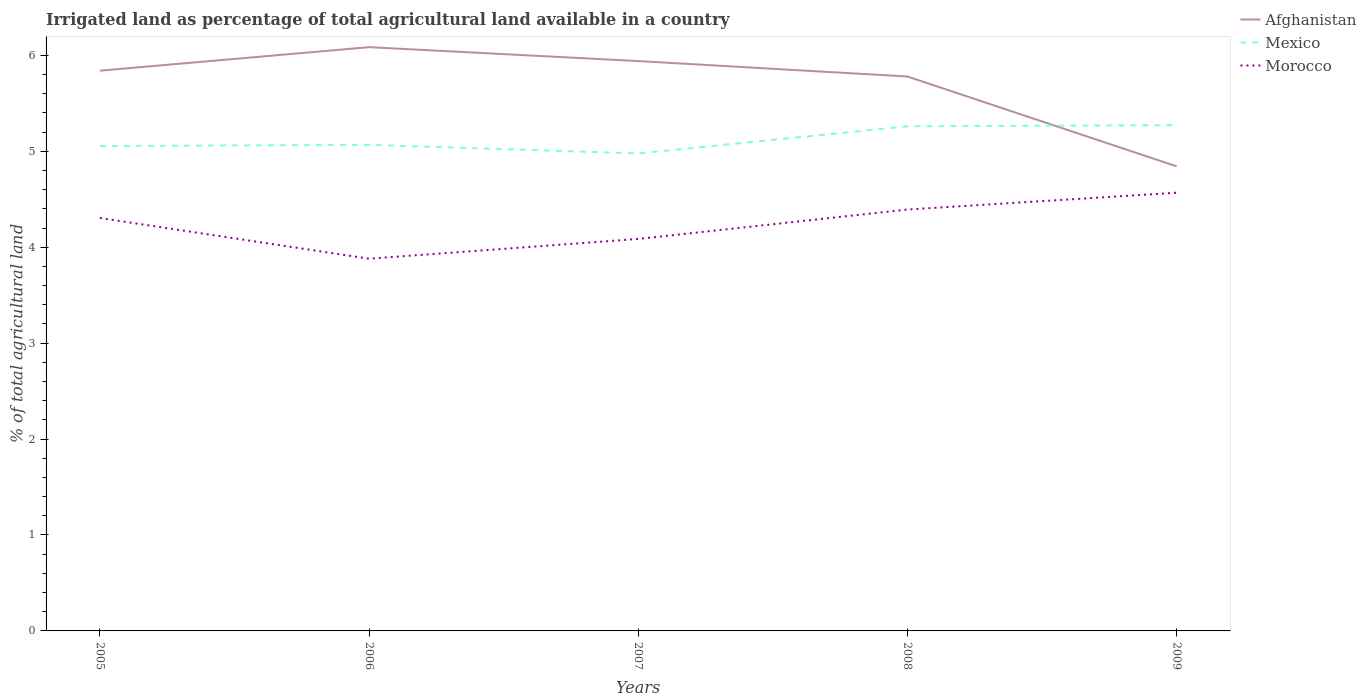Does the line corresponding to Morocco intersect with the line corresponding to Mexico?
Offer a very short reply. No. Across all years, what is the maximum percentage of irrigated land in Afghanistan?
Your answer should be compact. 4.84. In which year was the percentage of irrigated land in Afghanistan maximum?
Provide a short and direct response. 2009. What is the total percentage of irrigated land in Morocco in the graph?
Your answer should be very brief. -0.31. What is the difference between the highest and the second highest percentage of irrigated land in Afghanistan?
Provide a short and direct response. 1.24. Is the percentage of irrigated land in Mexico strictly greater than the percentage of irrigated land in Afghanistan over the years?
Ensure brevity in your answer.  No. How many lines are there?
Ensure brevity in your answer.  3. What is the difference between two consecutive major ticks on the Y-axis?
Your answer should be compact. 1. Are the values on the major ticks of Y-axis written in scientific E-notation?
Provide a short and direct response. No. Does the graph contain any zero values?
Your answer should be very brief. No. Where does the legend appear in the graph?
Make the answer very short. Top right. How many legend labels are there?
Keep it short and to the point. 3. What is the title of the graph?
Keep it short and to the point. Irrigated land as percentage of total agricultural land available in a country. Does "Chile" appear as one of the legend labels in the graph?
Your answer should be compact. No. What is the label or title of the X-axis?
Keep it short and to the point. Years. What is the label or title of the Y-axis?
Offer a very short reply. % of total agricultural land. What is the % of total agricultural land in Afghanistan in 2005?
Provide a succinct answer. 5.84. What is the % of total agricultural land in Mexico in 2005?
Offer a terse response. 5.05. What is the % of total agricultural land in Morocco in 2005?
Ensure brevity in your answer.  4.3. What is the % of total agricultural land of Afghanistan in 2006?
Make the answer very short. 6.09. What is the % of total agricultural land of Mexico in 2006?
Ensure brevity in your answer.  5.07. What is the % of total agricultural land of Morocco in 2006?
Make the answer very short. 3.88. What is the % of total agricultural land of Afghanistan in 2007?
Keep it short and to the point. 5.94. What is the % of total agricultural land of Mexico in 2007?
Ensure brevity in your answer.  4.98. What is the % of total agricultural land in Morocco in 2007?
Your response must be concise. 4.09. What is the % of total agricultural land of Afghanistan in 2008?
Provide a short and direct response. 5.78. What is the % of total agricultural land in Mexico in 2008?
Offer a very short reply. 5.26. What is the % of total agricultural land of Morocco in 2008?
Keep it short and to the point. 4.39. What is the % of total agricultural land in Afghanistan in 2009?
Ensure brevity in your answer.  4.84. What is the % of total agricultural land of Mexico in 2009?
Keep it short and to the point. 5.27. What is the % of total agricultural land of Morocco in 2009?
Offer a very short reply. 4.57. Across all years, what is the maximum % of total agricultural land in Afghanistan?
Provide a short and direct response. 6.09. Across all years, what is the maximum % of total agricultural land of Mexico?
Your answer should be very brief. 5.27. Across all years, what is the maximum % of total agricultural land in Morocco?
Provide a succinct answer. 4.57. Across all years, what is the minimum % of total agricultural land in Afghanistan?
Ensure brevity in your answer.  4.84. Across all years, what is the minimum % of total agricultural land in Mexico?
Your answer should be very brief. 4.98. Across all years, what is the minimum % of total agricultural land in Morocco?
Your answer should be compact. 3.88. What is the total % of total agricultural land of Afghanistan in the graph?
Provide a short and direct response. 28.49. What is the total % of total agricultural land in Mexico in the graph?
Make the answer very short. 25.63. What is the total % of total agricultural land in Morocco in the graph?
Keep it short and to the point. 21.23. What is the difference between the % of total agricultural land in Afghanistan in 2005 and that in 2006?
Provide a short and direct response. -0.25. What is the difference between the % of total agricultural land in Mexico in 2005 and that in 2006?
Your response must be concise. -0.01. What is the difference between the % of total agricultural land of Morocco in 2005 and that in 2006?
Provide a short and direct response. 0.42. What is the difference between the % of total agricultural land of Afghanistan in 2005 and that in 2007?
Give a very brief answer. -0.1. What is the difference between the % of total agricultural land of Mexico in 2005 and that in 2007?
Keep it short and to the point. 0.08. What is the difference between the % of total agricultural land of Morocco in 2005 and that in 2007?
Provide a succinct answer. 0.22. What is the difference between the % of total agricultural land in Afghanistan in 2005 and that in 2008?
Give a very brief answer. 0.06. What is the difference between the % of total agricultural land in Mexico in 2005 and that in 2008?
Your answer should be compact. -0.21. What is the difference between the % of total agricultural land in Morocco in 2005 and that in 2008?
Your answer should be compact. -0.09. What is the difference between the % of total agricultural land of Mexico in 2005 and that in 2009?
Offer a very short reply. -0.22. What is the difference between the % of total agricultural land in Morocco in 2005 and that in 2009?
Offer a very short reply. -0.26. What is the difference between the % of total agricultural land in Afghanistan in 2006 and that in 2007?
Ensure brevity in your answer.  0.15. What is the difference between the % of total agricultural land in Mexico in 2006 and that in 2007?
Your answer should be compact. 0.09. What is the difference between the % of total agricultural land in Morocco in 2006 and that in 2007?
Your answer should be compact. -0.21. What is the difference between the % of total agricultural land of Afghanistan in 2006 and that in 2008?
Your response must be concise. 0.31. What is the difference between the % of total agricultural land of Mexico in 2006 and that in 2008?
Offer a terse response. -0.19. What is the difference between the % of total agricultural land of Morocco in 2006 and that in 2008?
Your response must be concise. -0.51. What is the difference between the % of total agricultural land of Afghanistan in 2006 and that in 2009?
Provide a succinct answer. 1.24. What is the difference between the % of total agricultural land of Mexico in 2006 and that in 2009?
Keep it short and to the point. -0.21. What is the difference between the % of total agricultural land of Morocco in 2006 and that in 2009?
Provide a succinct answer. -0.69. What is the difference between the % of total agricultural land in Afghanistan in 2007 and that in 2008?
Ensure brevity in your answer.  0.16. What is the difference between the % of total agricultural land in Mexico in 2007 and that in 2008?
Make the answer very short. -0.28. What is the difference between the % of total agricultural land of Morocco in 2007 and that in 2008?
Your answer should be compact. -0.31. What is the difference between the % of total agricultural land of Afghanistan in 2007 and that in 2009?
Your answer should be very brief. 1.1. What is the difference between the % of total agricultural land in Mexico in 2007 and that in 2009?
Your answer should be compact. -0.29. What is the difference between the % of total agricultural land of Morocco in 2007 and that in 2009?
Give a very brief answer. -0.48. What is the difference between the % of total agricultural land of Afghanistan in 2008 and that in 2009?
Your answer should be very brief. 0.94. What is the difference between the % of total agricultural land in Mexico in 2008 and that in 2009?
Provide a short and direct response. -0.01. What is the difference between the % of total agricultural land of Morocco in 2008 and that in 2009?
Keep it short and to the point. -0.18. What is the difference between the % of total agricultural land of Afghanistan in 2005 and the % of total agricultural land of Mexico in 2006?
Provide a succinct answer. 0.77. What is the difference between the % of total agricultural land in Afghanistan in 2005 and the % of total agricultural land in Morocco in 2006?
Give a very brief answer. 1.96. What is the difference between the % of total agricultural land of Mexico in 2005 and the % of total agricultural land of Morocco in 2006?
Offer a very short reply. 1.17. What is the difference between the % of total agricultural land in Afghanistan in 2005 and the % of total agricultural land in Mexico in 2007?
Offer a terse response. 0.86. What is the difference between the % of total agricultural land in Afghanistan in 2005 and the % of total agricultural land in Morocco in 2007?
Provide a succinct answer. 1.75. What is the difference between the % of total agricultural land of Mexico in 2005 and the % of total agricultural land of Morocco in 2007?
Offer a very short reply. 0.97. What is the difference between the % of total agricultural land of Afghanistan in 2005 and the % of total agricultural land of Mexico in 2008?
Ensure brevity in your answer.  0.58. What is the difference between the % of total agricultural land of Afghanistan in 2005 and the % of total agricultural land of Morocco in 2008?
Offer a very short reply. 1.45. What is the difference between the % of total agricultural land of Mexico in 2005 and the % of total agricultural land of Morocco in 2008?
Offer a very short reply. 0.66. What is the difference between the % of total agricultural land of Afghanistan in 2005 and the % of total agricultural land of Mexico in 2009?
Your response must be concise. 0.57. What is the difference between the % of total agricultural land of Afghanistan in 2005 and the % of total agricultural land of Morocco in 2009?
Provide a succinct answer. 1.27. What is the difference between the % of total agricultural land in Mexico in 2005 and the % of total agricultural land in Morocco in 2009?
Your answer should be compact. 0.49. What is the difference between the % of total agricultural land of Afghanistan in 2006 and the % of total agricultural land of Mexico in 2007?
Make the answer very short. 1.11. What is the difference between the % of total agricultural land of Afghanistan in 2006 and the % of total agricultural land of Morocco in 2007?
Your answer should be compact. 2. What is the difference between the % of total agricultural land in Mexico in 2006 and the % of total agricultural land in Morocco in 2007?
Make the answer very short. 0.98. What is the difference between the % of total agricultural land in Afghanistan in 2006 and the % of total agricultural land in Mexico in 2008?
Offer a terse response. 0.83. What is the difference between the % of total agricultural land of Afghanistan in 2006 and the % of total agricultural land of Morocco in 2008?
Make the answer very short. 1.69. What is the difference between the % of total agricultural land in Mexico in 2006 and the % of total agricultural land in Morocco in 2008?
Keep it short and to the point. 0.67. What is the difference between the % of total agricultural land in Afghanistan in 2006 and the % of total agricultural land in Mexico in 2009?
Offer a terse response. 0.81. What is the difference between the % of total agricultural land in Afghanistan in 2006 and the % of total agricultural land in Morocco in 2009?
Your response must be concise. 1.52. What is the difference between the % of total agricultural land of Mexico in 2006 and the % of total agricultural land of Morocco in 2009?
Your response must be concise. 0.5. What is the difference between the % of total agricultural land of Afghanistan in 2007 and the % of total agricultural land of Mexico in 2008?
Provide a short and direct response. 0.68. What is the difference between the % of total agricultural land in Afghanistan in 2007 and the % of total agricultural land in Morocco in 2008?
Provide a short and direct response. 1.55. What is the difference between the % of total agricultural land of Mexico in 2007 and the % of total agricultural land of Morocco in 2008?
Keep it short and to the point. 0.58. What is the difference between the % of total agricultural land of Afghanistan in 2007 and the % of total agricultural land of Mexico in 2009?
Provide a short and direct response. 0.67. What is the difference between the % of total agricultural land in Afghanistan in 2007 and the % of total agricultural land in Morocco in 2009?
Offer a terse response. 1.37. What is the difference between the % of total agricultural land in Mexico in 2007 and the % of total agricultural land in Morocco in 2009?
Provide a short and direct response. 0.41. What is the difference between the % of total agricultural land of Afghanistan in 2008 and the % of total agricultural land of Mexico in 2009?
Offer a terse response. 0.51. What is the difference between the % of total agricultural land of Afghanistan in 2008 and the % of total agricultural land of Morocco in 2009?
Your answer should be compact. 1.21. What is the difference between the % of total agricultural land of Mexico in 2008 and the % of total agricultural land of Morocco in 2009?
Offer a very short reply. 0.69. What is the average % of total agricultural land in Afghanistan per year?
Provide a succinct answer. 5.7. What is the average % of total agricultural land in Mexico per year?
Make the answer very short. 5.13. What is the average % of total agricultural land in Morocco per year?
Make the answer very short. 4.25. In the year 2005, what is the difference between the % of total agricultural land of Afghanistan and % of total agricultural land of Mexico?
Offer a very short reply. 0.79. In the year 2005, what is the difference between the % of total agricultural land of Afghanistan and % of total agricultural land of Morocco?
Provide a succinct answer. 1.54. In the year 2006, what is the difference between the % of total agricultural land of Afghanistan and % of total agricultural land of Mexico?
Provide a succinct answer. 1.02. In the year 2006, what is the difference between the % of total agricultural land in Afghanistan and % of total agricultural land in Morocco?
Ensure brevity in your answer.  2.21. In the year 2006, what is the difference between the % of total agricultural land of Mexico and % of total agricultural land of Morocco?
Provide a short and direct response. 1.19. In the year 2007, what is the difference between the % of total agricultural land in Afghanistan and % of total agricultural land in Mexico?
Make the answer very short. 0.96. In the year 2007, what is the difference between the % of total agricultural land in Afghanistan and % of total agricultural land in Morocco?
Offer a very short reply. 1.85. In the year 2007, what is the difference between the % of total agricultural land of Mexico and % of total agricultural land of Morocco?
Offer a very short reply. 0.89. In the year 2008, what is the difference between the % of total agricultural land of Afghanistan and % of total agricultural land of Mexico?
Offer a very short reply. 0.52. In the year 2008, what is the difference between the % of total agricultural land of Afghanistan and % of total agricultural land of Morocco?
Ensure brevity in your answer.  1.39. In the year 2008, what is the difference between the % of total agricultural land in Mexico and % of total agricultural land in Morocco?
Offer a terse response. 0.87. In the year 2009, what is the difference between the % of total agricultural land of Afghanistan and % of total agricultural land of Mexico?
Provide a short and direct response. -0.43. In the year 2009, what is the difference between the % of total agricultural land in Afghanistan and % of total agricultural land in Morocco?
Provide a short and direct response. 0.28. In the year 2009, what is the difference between the % of total agricultural land of Mexico and % of total agricultural land of Morocco?
Your answer should be very brief. 0.7. What is the ratio of the % of total agricultural land in Afghanistan in 2005 to that in 2006?
Ensure brevity in your answer.  0.96. What is the ratio of the % of total agricultural land in Mexico in 2005 to that in 2006?
Your answer should be very brief. 1. What is the ratio of the % of total agricultural land of Morocco in 2005 to that in 2006?
Give a very brief answer. 1.11. What is the ratio of the % of total agricultural land of Afghanistan in 2005 to that in 2007?
Keep it short and to the point. 0.98. What is the ratio of the % of total agricultural land in Mexico in 2005 to that in 2007?
Ensure brevity in your answer.  1.02. What is the ratio of the % of total agricultural land in Morocco in 2005 to that in 2007?
Provide a short and direct response. 1.05. What is the ratio of the % of total agricultural land of Afghanistan in 2005 to that in 2008?
Ensure brevity in your answer.  1.01. What is the ratio of the % of total agricultural land of Mexico in 2005 to that in 2008?
Ensure brevity in your answer.  0.96. What is the ratio of the % of total agricultural land in Afghanistan in 2005 to that in 2009?
Your response must be concise. 1.21. What is the ratio of the % of total agricultural land in Mexico in 2005 to that in 2009?
Offer a very short reply. 0.96. What is the ratio of the % of total agricultural land of Morocco in 2005 to that in 2009?
Your answer should be compact. 0.94. What is the ratio of the % of total agricultural land of Afghanistan in 2006 to that in 2007?
Your answer should be compact. 1.02. What is the ratio of the % of total agricultural land in Mexico in 2006 to that in 2007?
Provide a short and direct response. 1.02. What is the ratio of the % of total agricultural land of Morocco in 2006 to that in 2007?
Provide a succinct answer. 0.95. What is the ratio of the % of total agricultural land in Afghanistan in 2006 to that in 2008?
Ensure brevity in your answer.  1.05. What is the ratio of the % of total agricultural land in Mexico in 2006 to that in 2008?
Keep it short and to the point. 0.96. What is the ratio of the % of total agricultural land in Morocco in 2006 to that in 2008?
Your response must be concise. 0.88. What is the ratio of the % of total agricultural land in Afghanistan in 2006 to that in 2009?
Make the answer very short. 1.26. What is the ratio of the % of total agricultural land in Mexico in 2006 to that in 2009?
Offer a very short reply. 0.96. What is the ratio of the % of total agricultural land of Morocco in 2006 to that in 2009?
Your answer should be compact. 0.85. What is the ratio of the % of total agricultural land in Afghanistan in 2007 to that in 2008?
Keep it short and to the point. 1.03. What is the ratio of the % of total agricultural land of Mexico in 2007 to that in 2008?
Offer a very short reply. 0.95. What is the ratio of the % of total agricultural land of Morocco in 2007 to that in 2008?
Give a very brief answer. 0.93. What is the ratio of the % of total agricultural land in Afghanistan in 2007 to that in 2009?
Offer a very short reply. 1.23. What is the ratio of the % of total agricultural land in Mexico in 2007 to that in 2009?
Make the answer very short. 0.94. What is the ratio of the % of total agricultural land in Morocco in 2007 to that in 2009?
Your response must be concise. 0.89. What is the ratio of the % of total agricultural land of Afghanistan in 2008 to that in 2009?
Provide a succinct answer. 1.19. What is the ratio of the % of total agricultural land of Morocco in 2008 to that in 2009?
Your answer should be compact. 0.96. What is the difference between the highest and the second highest % of total agricultural land of Afghanistan?
Your answer should be compact. 0.15. What is the difference between the highest and the second highest % of total agricultural land of Mexico?
Keep it short and to the point. 0.01. What is the difference between the highest and the second highest % of total agricultural land of Morocco?
Keep it short and to the point. 0.18. What is the difference between the highest and the lowest % of total agricultural land in Afghanistan?
Offer a very short reply. 1.24. What is the difference between the highest and the lowest % of total agricultural land of Mexico?
Make the answer very short. 0.29. What is the difference between the highest and the lowest % of total agricultural land of Morocco?
Make the answer very short. 0.69. 